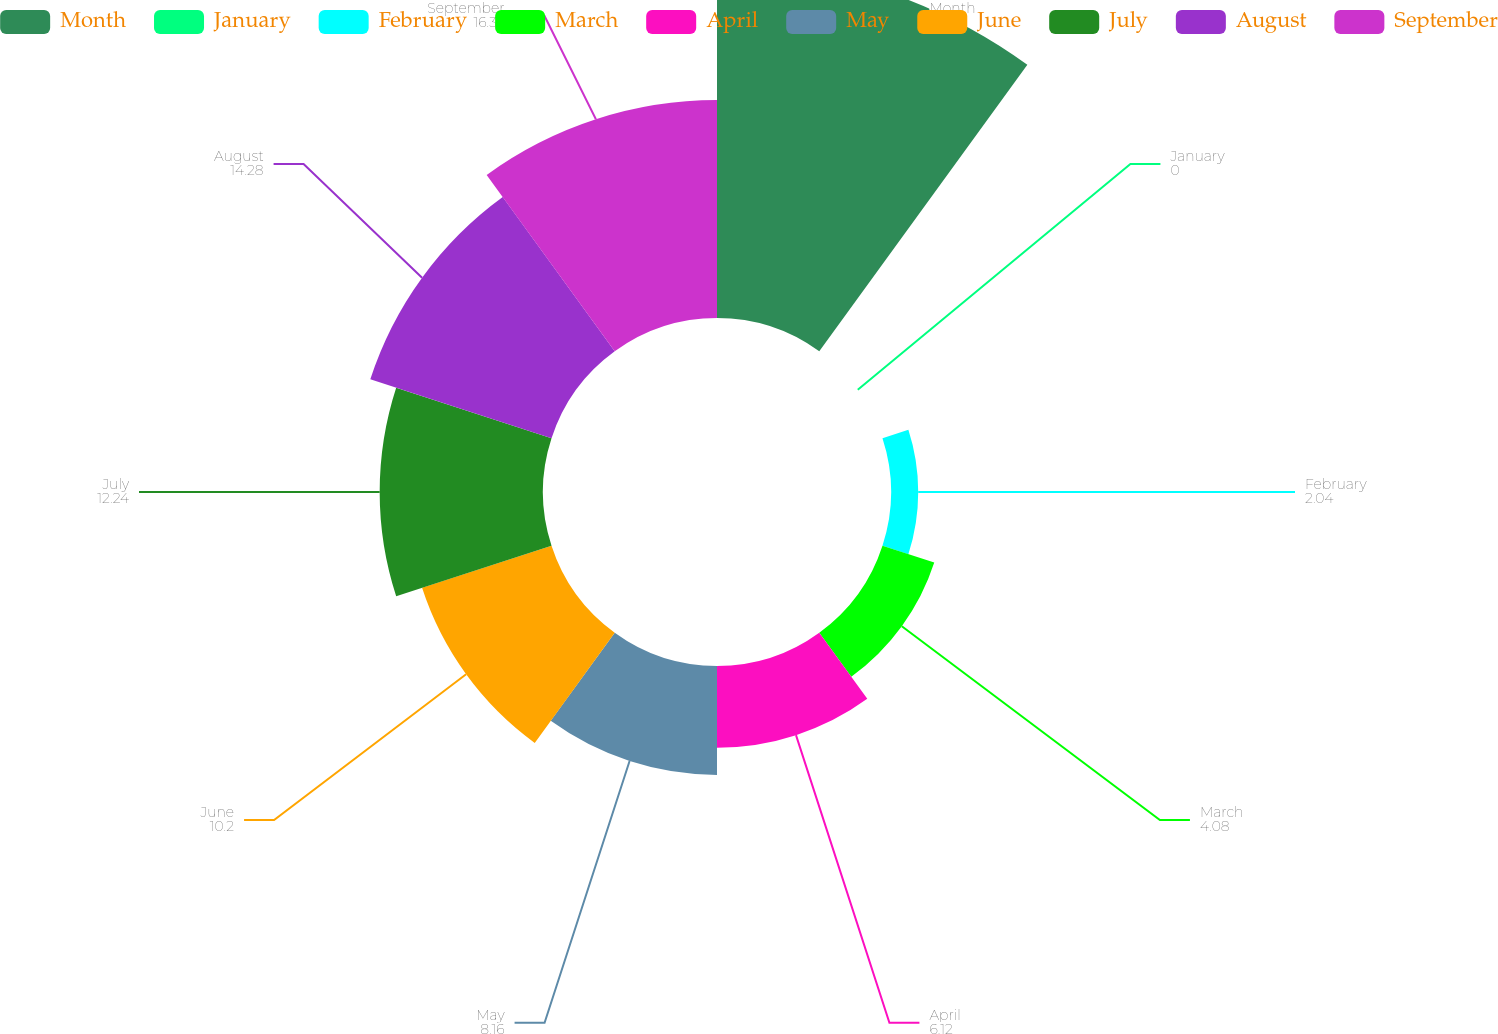<chart> <loc_0><loc_0><loc_500><loc_500><pie_chart><fcel>Month<fcel>January<fcel>February<fcel>March<fcel>April<fcel>May<fcel>June<fcel>July<fcel>August<fcel>September<nl><fcel>26.53%<fcel>0.0%<fcel>2.04%<fcel>4.08%<fcel>6.12%<fcel>8.16%<fcel>10.2%<fcel>12.24%<fcel>14.28%<fcel>16.33%<nl></chart> 